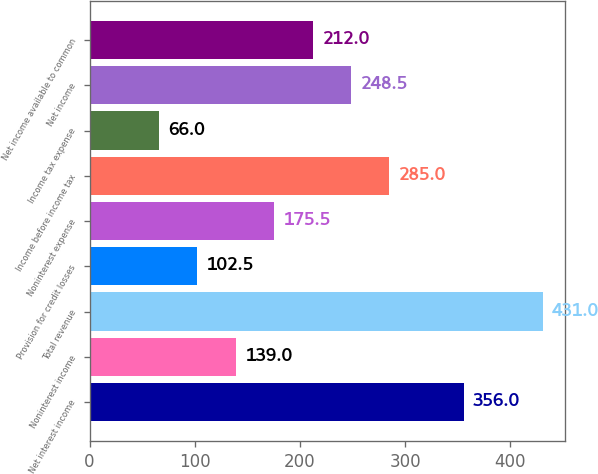Convert chart to OTSL. <chart><loc_0><loc_0><loc_500><loc_500><bar_chart><fcel>Net interest income<fcel>Noninterest income<fcel>Total revenue<fcel>Provision for credit losses<fcel>Noninterest expense<fcel>Income before income tax<fcel>Income tax expense<fcel>Net income<fcel>Net income available to common<nl><fcel>356<fcel>139<fcel>431<fcel>102.5<fcel>175.5<fcel>285<fcel>66<fcel>248.5<fcel>212<nl></chart> 